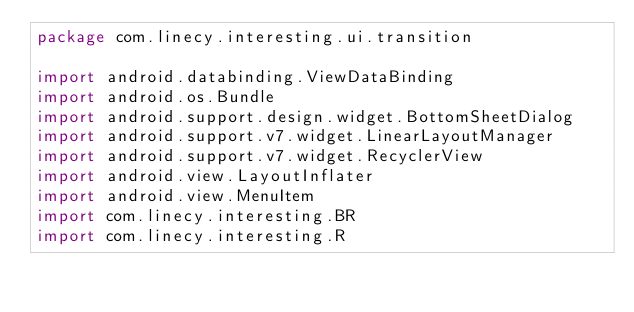<code> <loc_0><loc_0><loc_500><loc_500><_Kotlin_>package com.linecy.interesting.ui.transition

import android.databinding.ViewDataBinding
import android.os.Bundle
import android.support.design.widget.BottomSheetDialog
import android.support.v7.widget.LinearLayoutManager
import android.support.v7.widget.RecyclerView
import android.view.LayoutInflater
import android.view.MenuItem
import com.linecy.interesting.BR
import com.linecy.interesting.R</code> 